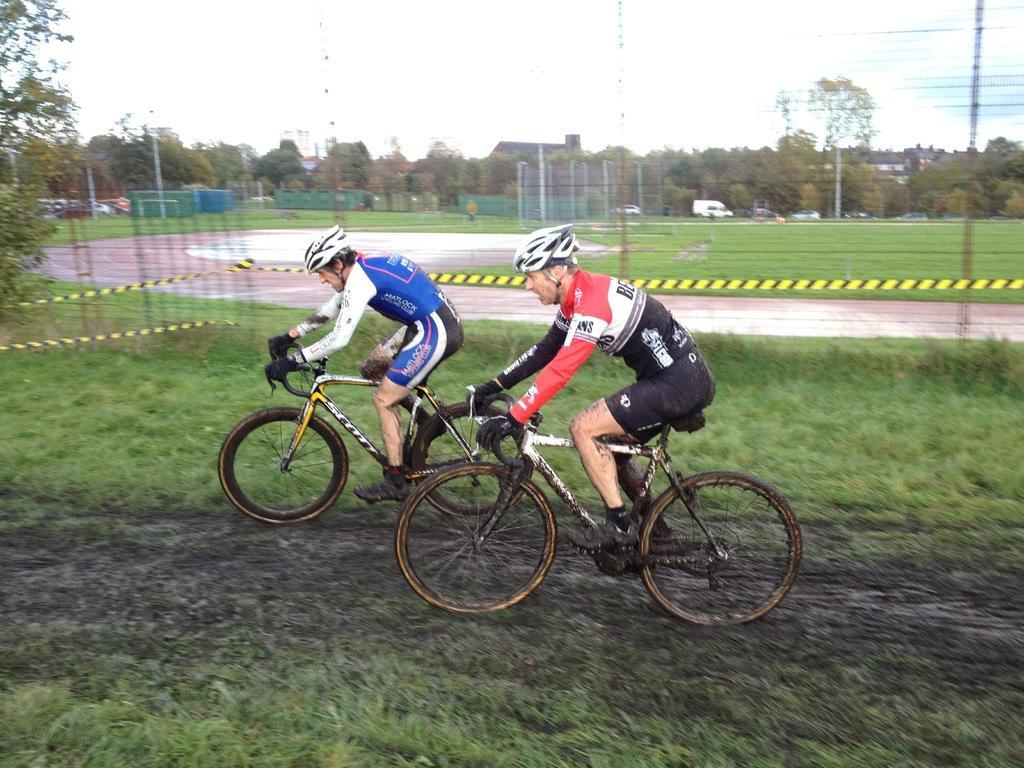Can you describe this image briefly? In this image, in the middle, we can see two men are riding a bicycle. In the background, we can see a net fence, trees, vehicles, buildings, pole. At the top, we can see a sky, at the bottom, we can see a grass and a land. 